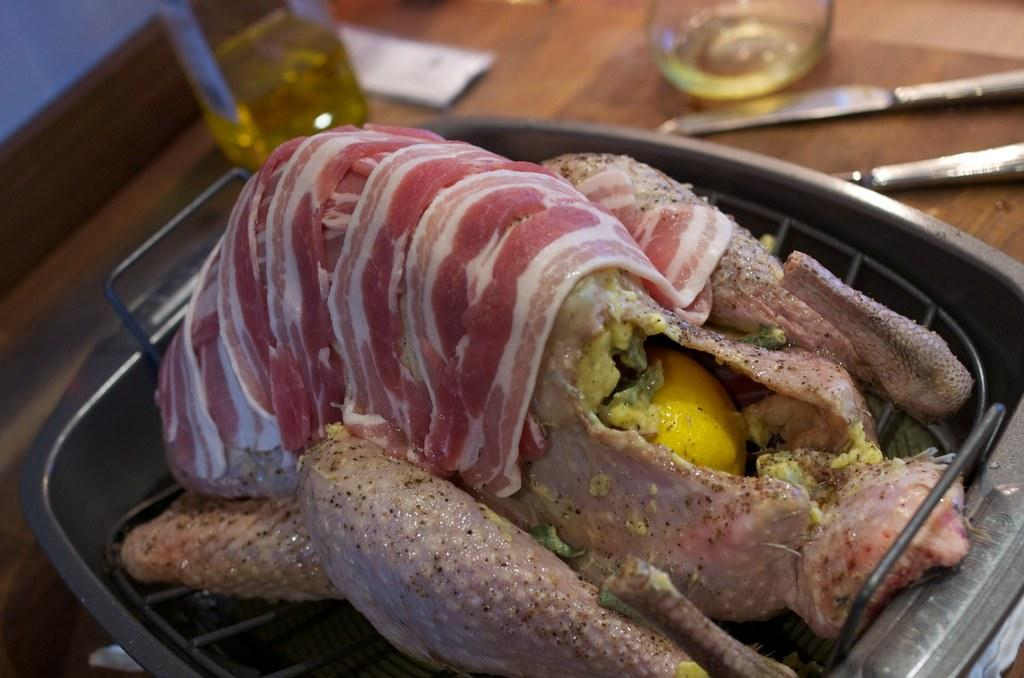What object can be seen holding various items in the image? There is a tray in the image. What type of animal is on the tray? A chicken is present on the tray. What other items are on the tray besides the chicken? There are meat pieces on the tray. What natural element is visible in the image? There is a tree in the image. What object is located near the tree? A knife is visible beside the tree. What type of beverage might be in the glass? There is a glass with a drink in the image. How many sacks are hanging from the tree in the image? There are no sacks present in the image. Is there a rifle visible in the image? There is no rifle present in the image. 